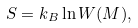<formula> <loc_0><loc_0><loc_500><loc_500>S = k _ { B } \ln W ( M ) ,</formula> 